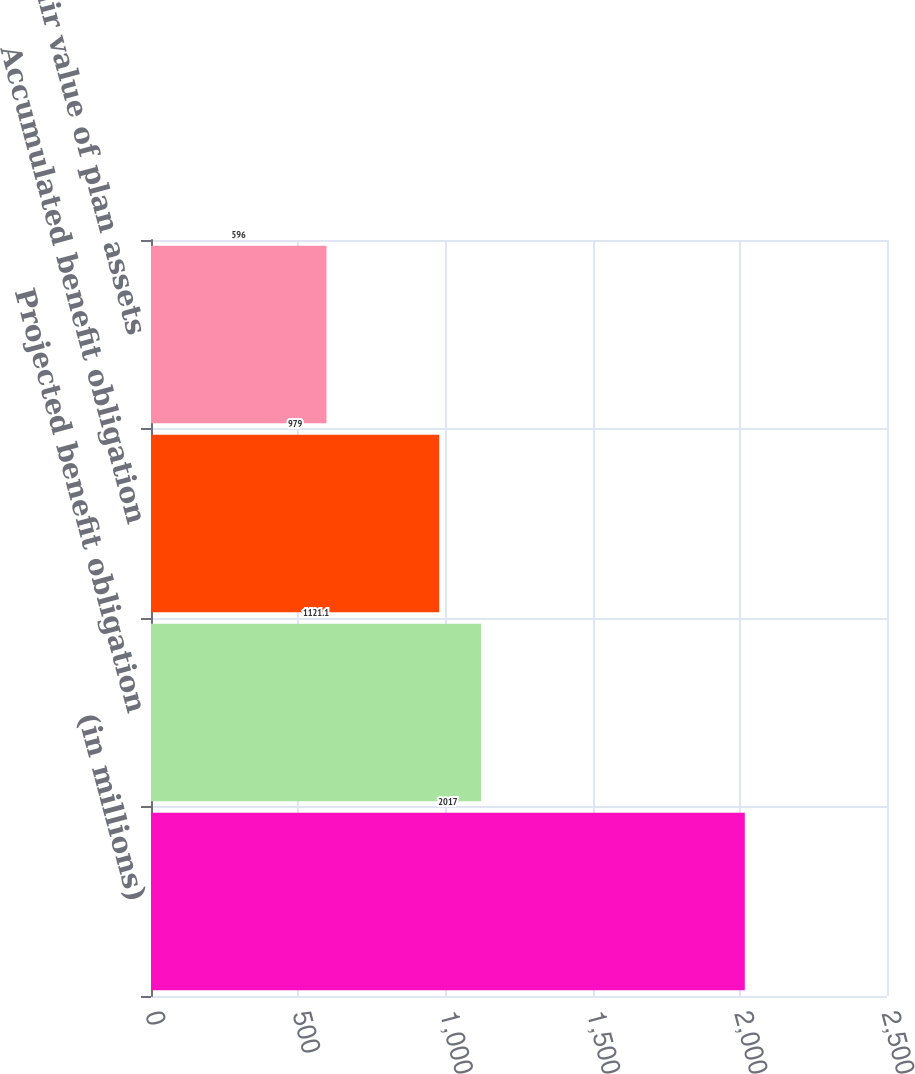Convert chart. <chart><loc_0><loc_0><loc_500><loc_500><bar_chart><fcel>(in millions)<fcel>Projected benefit obligation<fcel>Accumulated benefit obligation<fcel>Fair value of plan assets<nl><fcel>2017<fcel>1121.1<fcel>979<fcel>596<nl></chart> 